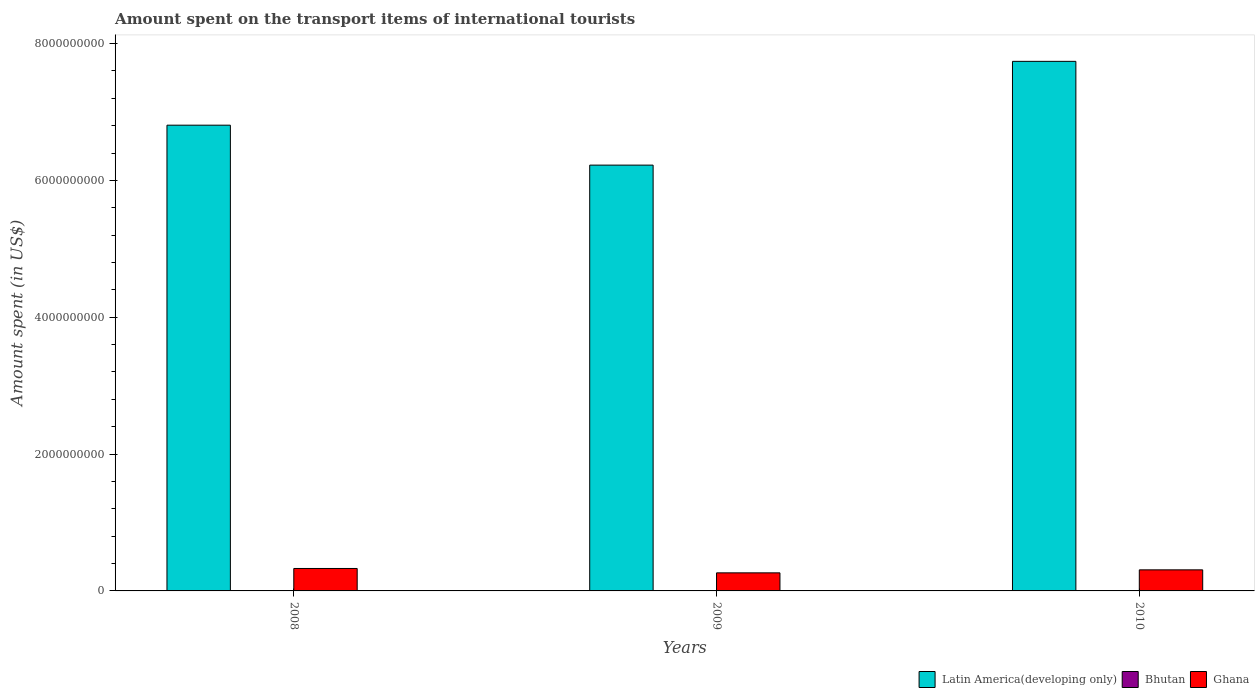How many different coloured bars are there?
Give a very brief answer. 3. Are the number of bars on each tick of the X-axis equal?
Make the answer very short. Yes. How many bars are there on the 1st tick from the left?
Your response must be concise. 3. How many bars are there on the 2nd tick from the right?
Ensure brevity in your answer.  3. What is the label of the 2nd group of bars from the left?
Provide a succinct answer. 2009. In how many cases, is the number of bars for a given year not equal to the number of legend labels?
Ensure brevity in your answer.  0. What is the amount spent on the transport items of international tourists in Ghana in 2009?
Provide a short and direct response. 2.64e+08. Across all years, what is the maximum amount spent on the transport items of international tourists in Latin America(developing only)?
Keep it short and to the point. 7.74e+09. Across all years, what is the minimum amount spent on the transport items of international tourists in Latin America(developing only)?
Offer a terse response. 6.22e+09. In which year was the amount spent on the transport items of international tourists in Ghana minimum?
Ensure brevity in your answer.  2009. What is the total amount spent on the transport items of international tourists in Bhutan in the graph?
Your response must be concise. 4.00e+06. What is the difference between the amount spent on the transport items of international tourists in Latin America(developing only) in 2010 and the amount spent on the transport items of international tourists in Bhutan in 2009?
Provide a succinct answer. 7.74e+09. What is the average amount spent on the transport items of international tourists in Latin America(developing only) per year?
Your response must be concise. 6.92e+09. In the year 2008, what is the difference between the amount spent on the transport items of international tourists in Bhutan and amount spent on the transport items of international tourists in Ghana?
Provide a short and direct response. -3.27e+08. What is the ratio of the amount spent on the transport items of international tourists in Ghana in 2008 to that in 2009?
Offer a very short reply. 1.24. Is the difference between the amount spent on the transport items of international tourists in Bhutan in 2008 and 2010 greater than the difference between the amount spent on the transport items of international tourists in Ghana in 2008 and 2010?
Your response must be concise. No. What is the difference between the highest and the second highest amount spent on the transport items of international tourists in Latin America(developing only)?
Your response must be concise. 9.33e+08. What is the difference between the highest and the lowest amount spent on the transport items of international tourists in Ghana?
Provide a short and direct response. 6.40e+07. In how many years, is the amount spent on the transport items of international tourists in Latin America(developing only) greater than the average amount spent on the transport items of international tourists in Latin America(developing only) taken over all years?
Keep it short and to the point. 1. What does the 2nd bar from the right in 2009 represents?
Your response must be concise. Bhutan. Is it the case that in every year, the sum of the amount spent on the transport items of international tourists in Ghana and amount spent on the transport items of international tourists in Latin America(developing only) is greater than the amount spent on the transport items of international tourists in Bhutan?
Keep it short and to the point. Yes. How many years are there in the graph?
Ensure brevity in your answer.  3. What is the difference between two consecutive major ticks on the Y-axis?
Offer a terse response. 2.00e+09. Does the graph contain any zero values?
Ensure brevity in your answer.  No. Where does the legend appear in the graph?
Provide a succinct answer. Bottom right. What is the title of the graph?
Provide a short and direct response. Amount spent on the transport items of international tourists. Does "Isle of Man" appear as one of the legend labels in the graph?
Offer a very short reply. No. What is the label or title of the X-axis?
Keep it short and to the point. Years. What is the label or title of the Y-axis?
Keep it short and to the point. Amount spent (in US$). What is the Amount spent (in US$) in Latin America(developing only) in 2008?
Your answer should be compact. 6.81e+09. What is the Amount spent (in US$) in Ghana in 2008?
Offer a terse response. 3.28e+08. What is the Amount spent (in US$) of Latin America(developing only) in 2009?
Your answer should be very brief. 6.22e+09. What is the Amount spent (in US$) of Bhutan in 2009?
Keep it short and to the point. 1.00e+06. What is the Amount spent (in US$) in Ghana in 2009?
Ensure brevity in your answer.  2.64e+08. What is the Amount spent (in US$) in Latin America(developing only) in 2010?
Make the answer very short. 7.74e+09. What is the Amount spent (in US$) of Bhutan in 2010?
Make the answer very short. 2.00e+06. What is the Amount spent (in US$) of Ghana in 2010?
Make the answer very short. 3.08e+08. Across all years, what is the maximum Amount spent (in US$) of Latin America(developing only)?
Ensure brevity in your answer.  7.74e+09. Across all years, what is the maximum Amount spent (in US$) in Ghana?
Your response must be concise. 3.28e+08. Across all years, what is the minimum Amount spent (in US$) in Latin America(developing only)?
Your response must be concise. 6.22e+09. Across all years, what is the minimum Amount spent (in US$) of Bhutan?
Keep it short and to the point. 1.00e+06. Across all years, what is the minimum Amount spent (in US$) in Ghana?
Your response must be concise. 2.64e+08. What is the total Amount spent (in US$) in Latin America(developing only) in the graph?
Give a very brief answer. 2.08e+1. What is the total Amount spent (in US$) in Bhutan in the graph?
Make the answer very short. 4.00e+06. What is the total Amount spent (in US$) in Ghana in the graph?
Offer a very short reply. 9.00e+08. What is the difference between the Amount spent (in US$) of Latin America(developing only) in 2008 and that in 2009?
Your answer should be compact. 5.84e+08. What is the difference between the Amount spent (in US$) in Ghana in 2008 and that in 2009?
Make the answer very short. 6.40e+07. What is the difference between the Amount spent (in US$) in Latin America(developing only) in 2008 and that in 2010?
Your answer should be compact. -9.33e+08. What is the difference between the Amount spent (in US$) in Bhutan in 2008 and that in 2010?
Offer a terse response. -1.00e+06. What is the difference between the Amount spent (in US$) in Latin America(developing only) in 2009 and that in 2010?
Your answer should be very brief. -1.52e+09. What is the difference between the Amount spent (in US$) in Ghana in 2009 and that in 2010?
Make the answer very short. -4.40e+07. What is the difference between the Amount spent (in US$) in Latin America(developing only) in 2008 and the Amount spent (in US$) in Bhutan in 2009?
Your answer should be compact. 6.81e+09. What is the difference between the Amount spent (in US$) in Latin America(developing only) in 2008 and the Amount spent (in US$) in Ghana in 2009?
Keep it short and to the point. 6.54e+09. What is the difference between the Amount spent (in US$) of Bhutan in 2008 and the Amount spent (in US$) of Ghana in 2009?
Keep it short and to the point. -2.63e+08. What is the difference between the Amount spent (in US$) of Latin America(developing only) in 2008 and the Amount spent (in US$) of Bhutan in 2010?
Keep it short and to the point. 6.80e+09. What is the difference between the Amount spent (in US$) of Latin America(developing only) in 2008 and the Amount spent (in US$) of Ghana in 2010?
Your answer should be very brief. 6.50e+09. What is the difference between the Amount spent (in US$) in Bhutan in 2008 and the Amount spent (in US$) in Ghana in 2010?
Offer a very short reply. -3.07e+08. What is the difference between the Amount spent (in US$) in Latin America(developing only) in 2009 and the Amount spent (in US$) in Bhutan in 2010?
Ensure brevity in your answer.  6.22e+09. What is the difference between the Amount spent (in US$) of Latin America(developing only) in 2009 and the Amount spent (in US$) of Ghana in 2010?
Offer a terse response. 5.92e+09. What is the difference between the Amount spent (in US$) in Bhutan in 2009 and the Amount spent (in US$) in Ghana in 2010?
Provide a succinct answer. -3.07e+08. What is the average Amount spent (in US$) in Latin America(developing only) per year?
Keep it short and to the point. 6.92e+09. What is the average Amount spent (in US$) of Bhutan per year?
Your answer should be very brief. 1.33e+06. What is the average Amount spent (in US$) of Ghana per year?
Offer a terse response. 3.00e+08. In the year 2008, what is the difference between the Amount spent (in US$) of Latin America(developing only) and Amount spent (in US$) of Bhutan?
Give a very brief answer. 6.81e+09. In the year 2008, what is the difference between the Amount spent (in US$) of Latin America(developing only) and Amount spent (in US$) of Ghana?
Provide a short and direct response. 6.48e+09. In the year 2008, what is the difference between the Amount spent (in US$) in Bhutan and Amount spent (in US$) in Ghana?
Provide a short and direct response. -3.27e+08. In the year 2009, what is the difference between the Amount spent (in US$) of Latin America(developing only) and Amount spent (in US$) of Bhutan?
Your answer should be compact. 6.22e+09. In the year 2009, what is the difference between the Amount spent (in US$) of Latin America(developing only) and Amount spent (in US$) of Ghana?
Your response must be concise. 5.96e+09. In the year 2009, what is the difference between the Amount spent (in US$) in Bhutan and Amount spent (in US$) in Ghana?
Ensure brevity in your answer.  -2.63e+08. In the year 2010, what is the difference between the Amount spent (in US$) in Latin America(developing only) and Amount spent (in US$) in Bhutan?
Your response must be concise. 7.74e+09. In the year 2010, what is the difference between the Amount spent (in US$) in Latin America(developing only) and Amount spent (in US$) in Ghana?
Ensure brevity in your answer.  7.43e+09. In the year 2010, what is the difference between the Amount spent (in US$) in Bhutan and Amount spent (in US$) in Ghana?
Offer a terse response. -3.06e+08. What is the ratio of the Amount spent (in US$) in Latin America(developing only) in 2008 to that in 2009?
Provide a short and direct response. 1.09. What is the ratio of the Amount spent (in US$) of Bhutan in 2008 to that in 2009?
Keep it short and to the point. 1. What is the ratio of the Amount spent (in US$) of Ghana in 2008 to that in 2009?
Offer a very short reply. 1.24. What is the ratio of the Amount spent (in US$) of Latin America(developing only) in 2008 to that in 2010?
Provide a short and direct response. 0.88. What is the ratio of the Amount spent (in US$) of Bhutan in 2008 to that in 2010?
Offer a very short reply. 0.5. What is the ratio of the Amount spent (in US$) of Ghana in 2008 to that in 2010?
Your answer should be very brief. 1.06. What is the ratio of the Amount spent (in US$) of Latin America(developing only) in 2009 to that in 2010?
Offer a very short reply. 0.8. What is the ratio of the Amount spent (in US$) in Ghana in 2009 to that in 2010?
Give a very brief answer. 0.86. What is the difference between the highest and the second highest Amount spent (in US$) of Latin America(developing only)?
Ensure brevity in your answer.  9.33e+08. What is the difference between the highest and the second highest Amount spent (in US$) of Bhutan?
Ensure brevity in your answer.  1.00e+06. What is the difference between the highest and the lowest Amount spent (in US$) in Latin America(developing only)?
Provide a short and direct response. 1.52e+09. What is the difference between the highest and the lowest Amount spent (in US$) of Ghana?
Your answer should be compact. 6.40e+07. 